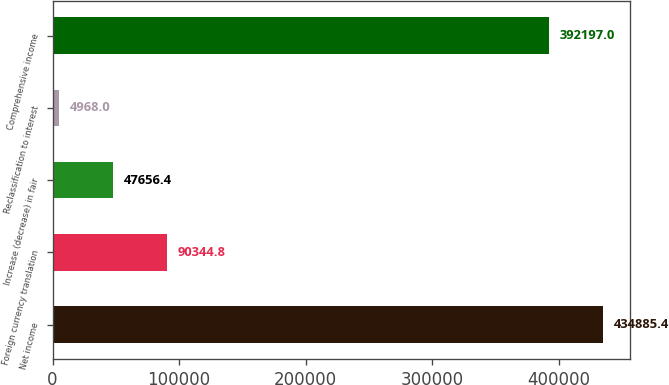<chart> <loc_0><loc_0><loc_500><loc_500><bar_chart><fcel>Net income<fcel>Foreign currency translation<fcel>Increase (decrease) in fair<fcel>Reclassification to interest<fcel>Comprehensive income<nl><fcel>434885<fcel>90344.8<fcel>47656.4<fcel>4968<fcel>392197<nl></chart> 